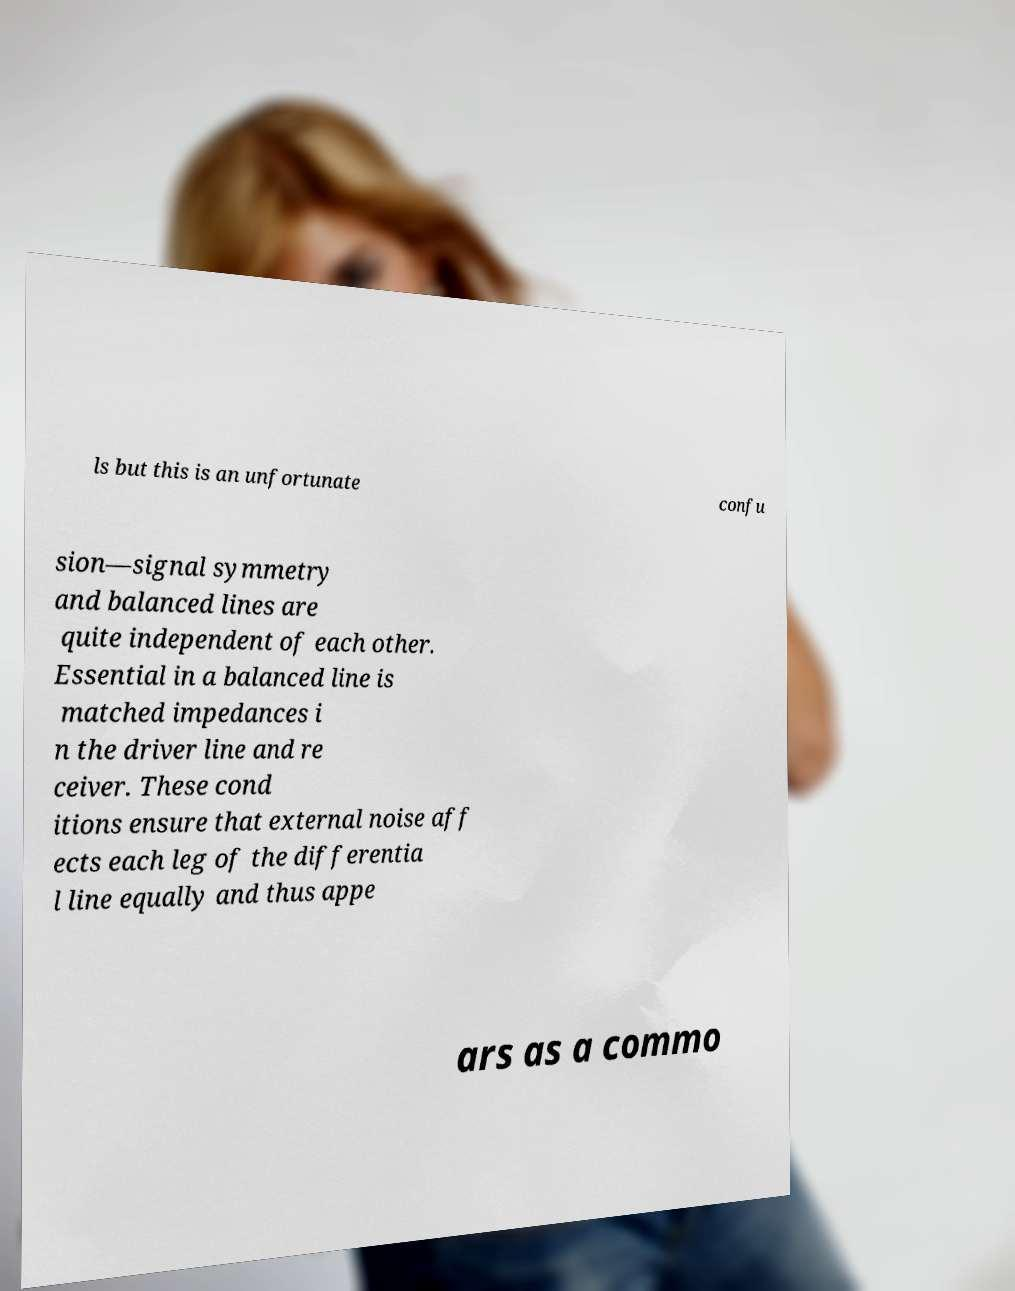What messages or text are displayed in this image? I need them in a readable, typed format. ls but this is an unfortunate confu sion—signal symmetry and balanced lines are quite independent of each other. Essential in a balanced line is matched impedances i n the driver line and re ceiver. These cond itions ensure that external noise aff ects each leg of the differentia l line equally and thus appe ars as a commo 